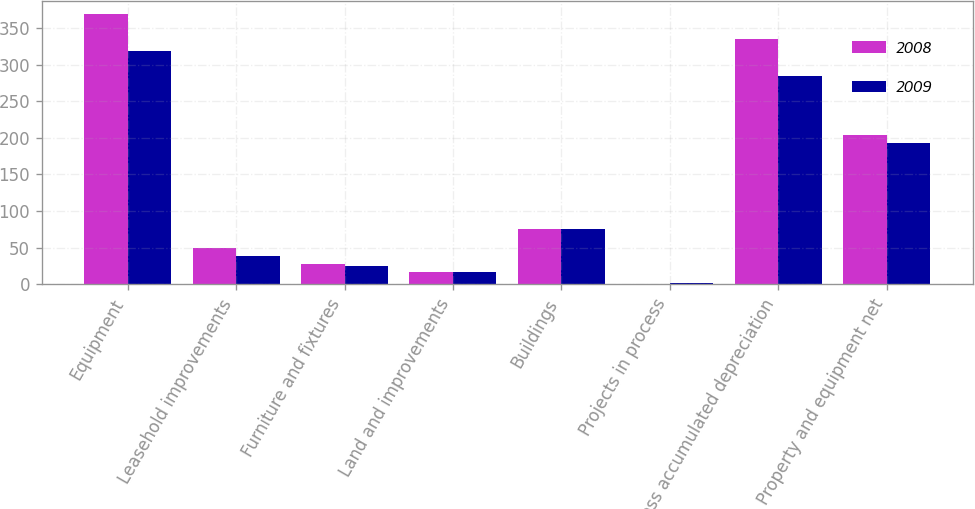Convert chart to OTSL. <chart><loc_0><loc_0><loc_500><loc_500><stacked_bar_chart><ecel><fcel>Equipment<fcel>Leasehold improvements<fcel>Furniture and fixtures<fcel>Land and improvements<fcel>Buildings<fcel>Projects in process<fcel>Less accumulated depreciation<fcel>Property and equipment net<nl><fcel>2008<fcel>368.5<fcel>50<fcel>28.1<fcel>16.9<fcel>75.2<fcel>1<fcel>335.4<fcel>204.3<nl><fcel>2009<fcel>319.2<fcel>38.9<fcel>25.2<fcel>16.9<fcel>74.8<fcel>1.3<fcel>284<fcel>192.3<nl></chart> 